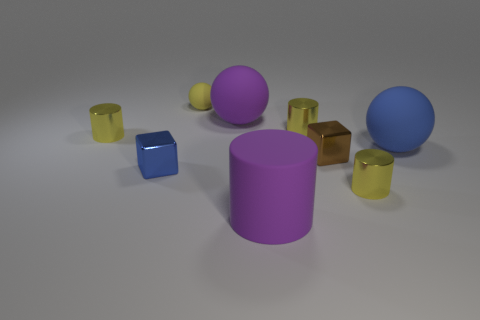What number of other things are there of the same size as the yellow ball?
Keep it short and to the point. 5. What is the color of the large matte cylinder?
Offer a terse response. Purple. What is the yellow object to the left of the small yellow sphere made of?
Keep it short and to the point. Metal. Is the number of matte spheres in front of the yellow sphere the same as the number of big cyan balls?
Provide a short and direct response. No. Does the brown metal object have the same shape as the tiny blue object?
Provide a short and direct response. Yes. Is there anything else that is the same color as the small sphere?
Keep it short and to the point. Yes. What is the shape of the thing that is behind the tiny blue thing and right of the tiny brown shiny block?
Offer a very short reply. Sphere. Are there an equal number of tiny yellow cylinders to the right of the blue cube and big purple things that are behind the rubber cylinder?
Your answer should be compact. No. How many cylinders are either red shiny objects or big purple things?
Give a very brief answer. 1. How many small brown cubes are the same material as the blue sphere?
Make the answer very short. 0. 